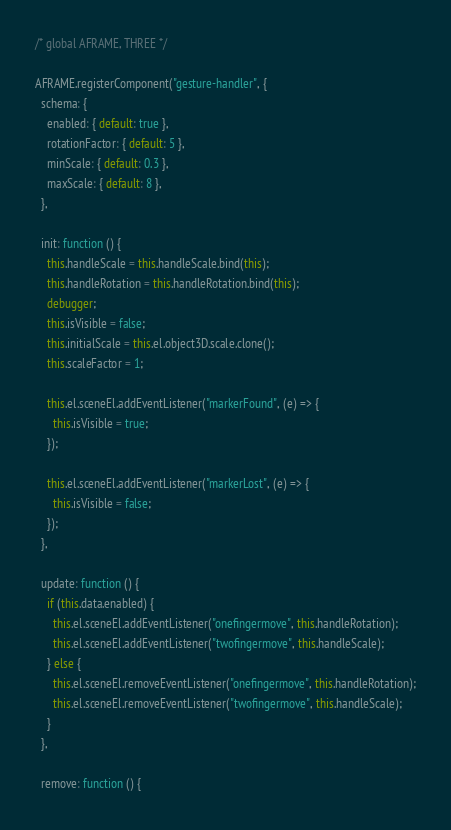<code> <loc_0><loc_0><loc_500><loc_500><_JavaScript_>/* global AFRAME, THREE */

AFRAME.registerComponent("gesture-handler", {
  schema: {
    enabled: { default: true },
    rotationFactor: { default: 5 },
    minScale: { default: 0.3 },
    maxScale: { default: 8 },
  },

  init: function () {
    this.handleScale = this.handleScale.bind(this);
    this.handleRotation = this.handleRotation.bind(this);
    debugger;
    this.isVisible = false;
    this.initialScale = this.el.object3D.scale.clone();
    this.scaleFactor = 1;

    this.el.sceneEl.addEventListener("markerFound", (e) => {
      this.isVisible = true;
    });

    this.el.sceneEl.addEventListener("markerLost", (e) => {
      this.isVisible = false;
    });
  },

  update: function () {
    if (this.data.enabled) {
      this.el.sceneEl.addEventListener("onefingermove", this.handleRotation);
      this.el.sceneEl.addEventListener("twofingermove", this.handleScale);
    } else {
      this.el.sceneEl.removeEventListener("onefingermove", this.handleRotation);
      this.el.sceneEl.removeEventListener("twofingermove", this.handleScale);
    }
  },

  remove: function () {</code> 